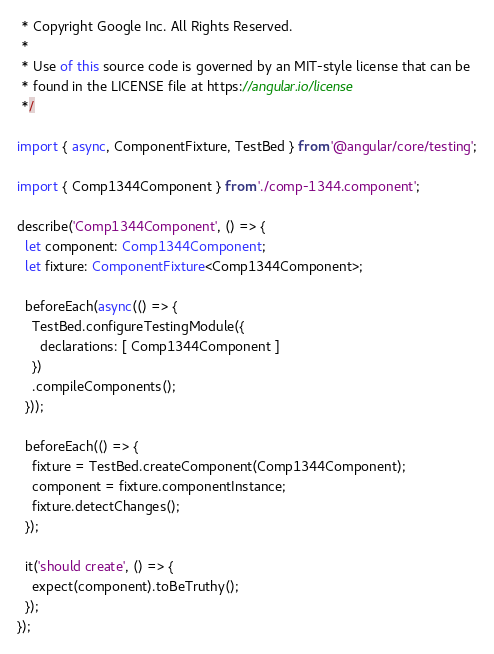<code> <loc_0><loc_0><loc_500><loc_500><_TypeScript_> * Copyright Google Inc. All Rights Reserved.
 *
 * Use of this source code is governed by an MIT-style license that can be
 * found in the LICENSE file at https://angular.io/license
 */

import { async, ComponentFixture, TestBed } from '@angular/core/testing';

import { Comp1344Component } from './comp-1344.component';

describe('Comp1344Component', () => {
  let component: Comp1344Component;
  let fixture: ComponentFixture<Comp1344Component>;

  beforeEach(async(() => {
    TestBed.configureTestingModule({
      declarations: [ Comp1344Component ]
    })
    .compileComponents();
  }));

  beforeEach(() => {
    fixture = TestBed.createComponent(Comp1344Component);
    component = fixture.componentInstance;
    fixture.detectChanges();
  });

  it('should create', () => {
    expect(component).toBeTruthy();
  });
});
</code> 